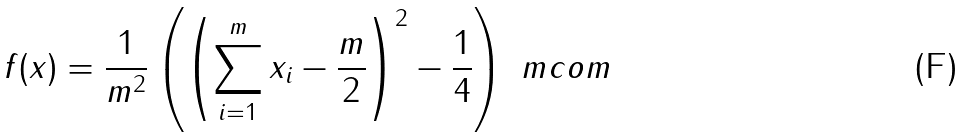Convert formula to latex. <formula><loc_0><loc_0><loc_500><loc_500>f ( x ) = \frac { 1 } { m ^ { 2 } } \left ( \left ( \sum _ { i = 1 } ^ { m } x _ { i } - \frac { m } { 2 } \right ) ^ { 2 } - \frac { 1 } { 4 } \right ) \ m c o m</formula> 